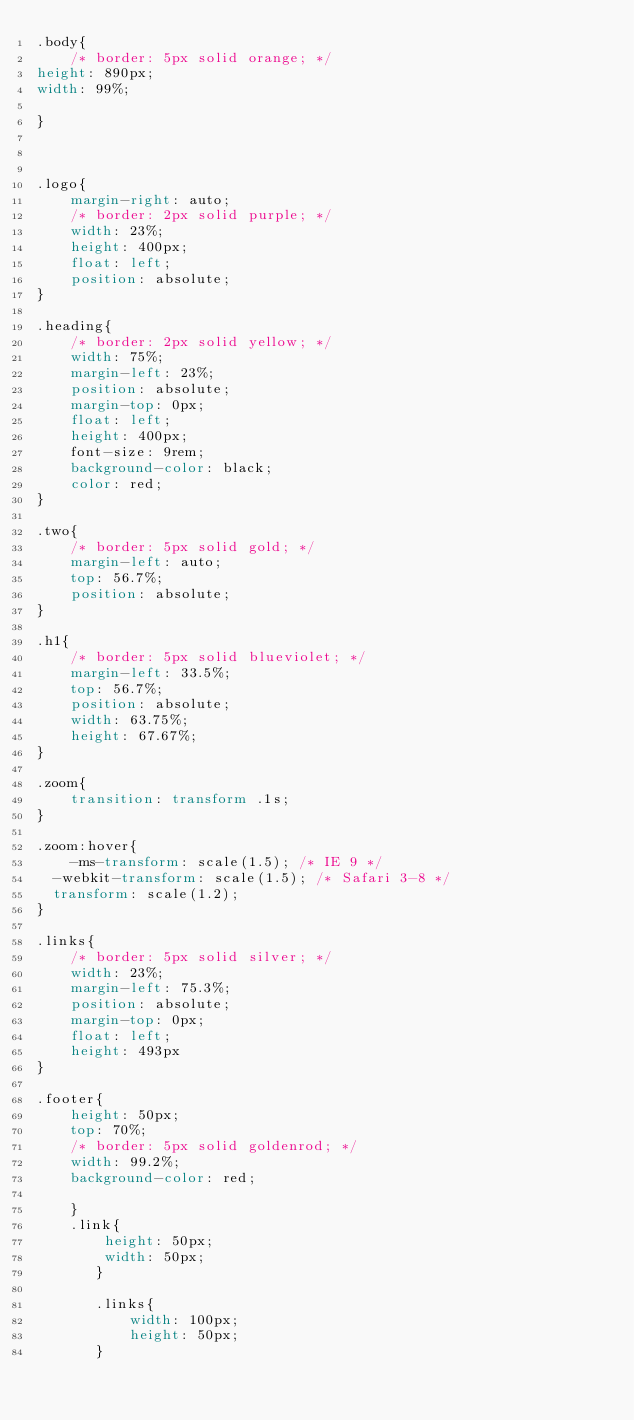Convert code to text. <code><loc_0><loc_0><loc_500><loc_500><_CSS_>.body{
    /* border: 5px solid orange; */
height: 890px;
width: 99%;

}



.logo{
    margin-right: auto;
    /* border: 2px solid purple; */
    width: 23%;
    height: 400px;
    float: left;
    position: absolute;
}

.heading{
    /* border: 2px solid yellow; */
    width: 75%;
    margin-left: 23%;
    position: absolute;
    margin-top: 0px;
    float: left;
    height: 400px;
    font-size: 9rem;
    background-color: black;
    color: red;
}

.two{
    /* border: 5px solid gold; */
    margin-left: auto;
    top: 56.7%;
    position: absolute;
}

.h1{
    /* border: 5px solid blueviolet; */
    margin-left: 33.5%;
    top: 56.7%;
    position: absolute;
    width: 63.75%;
    height: 67.67%;
}

.zoom{
    transition: transform .1s;
}

.zoom:hover{
    -ms-transform: scale(1.5); /* IE 9 */
  -webkit-transform: scale(1.5); /* Safari 3-8 */
  transform: scale(1.2); 
}

.links{
    /* border: 5px solid silver; */
    width: 23%;
    margin-left: 75.3%;
    position: absolute;
    margin-top: 0px;
    float: left;
    height: 493px
}

.footer{
    height: 50px;
    top: 70%;
    /* border: 5px solid goldenrod; */
    width: 99.2%;
    background-color: red;

    }
    .link{
        height: 50px;
        width: 50px;
       }
       
       .links{
           width: 100px;
           height: 50px;
       }</code> 